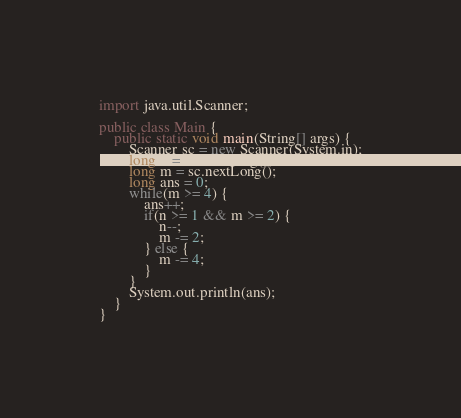Convert code to text. <code><loc_0><loc_0><loc_500><loc_500><_Java_>import java.util.Scanner;

public class Main {
	public static void main(String[] args) {
		Scanner sc = new Scanner(System.in);
		long n = sc.nextLong();
		long m = sc.nextLong();
		long ans = 0;
		while(m >= 4) {
			ans++;
			if(n >= 1 && m >= 2) {
				n--;
				m -= 2;
			} else {
				m -= 4;
			}
		}
		System.out.println(ans);
	}
}
</code> 